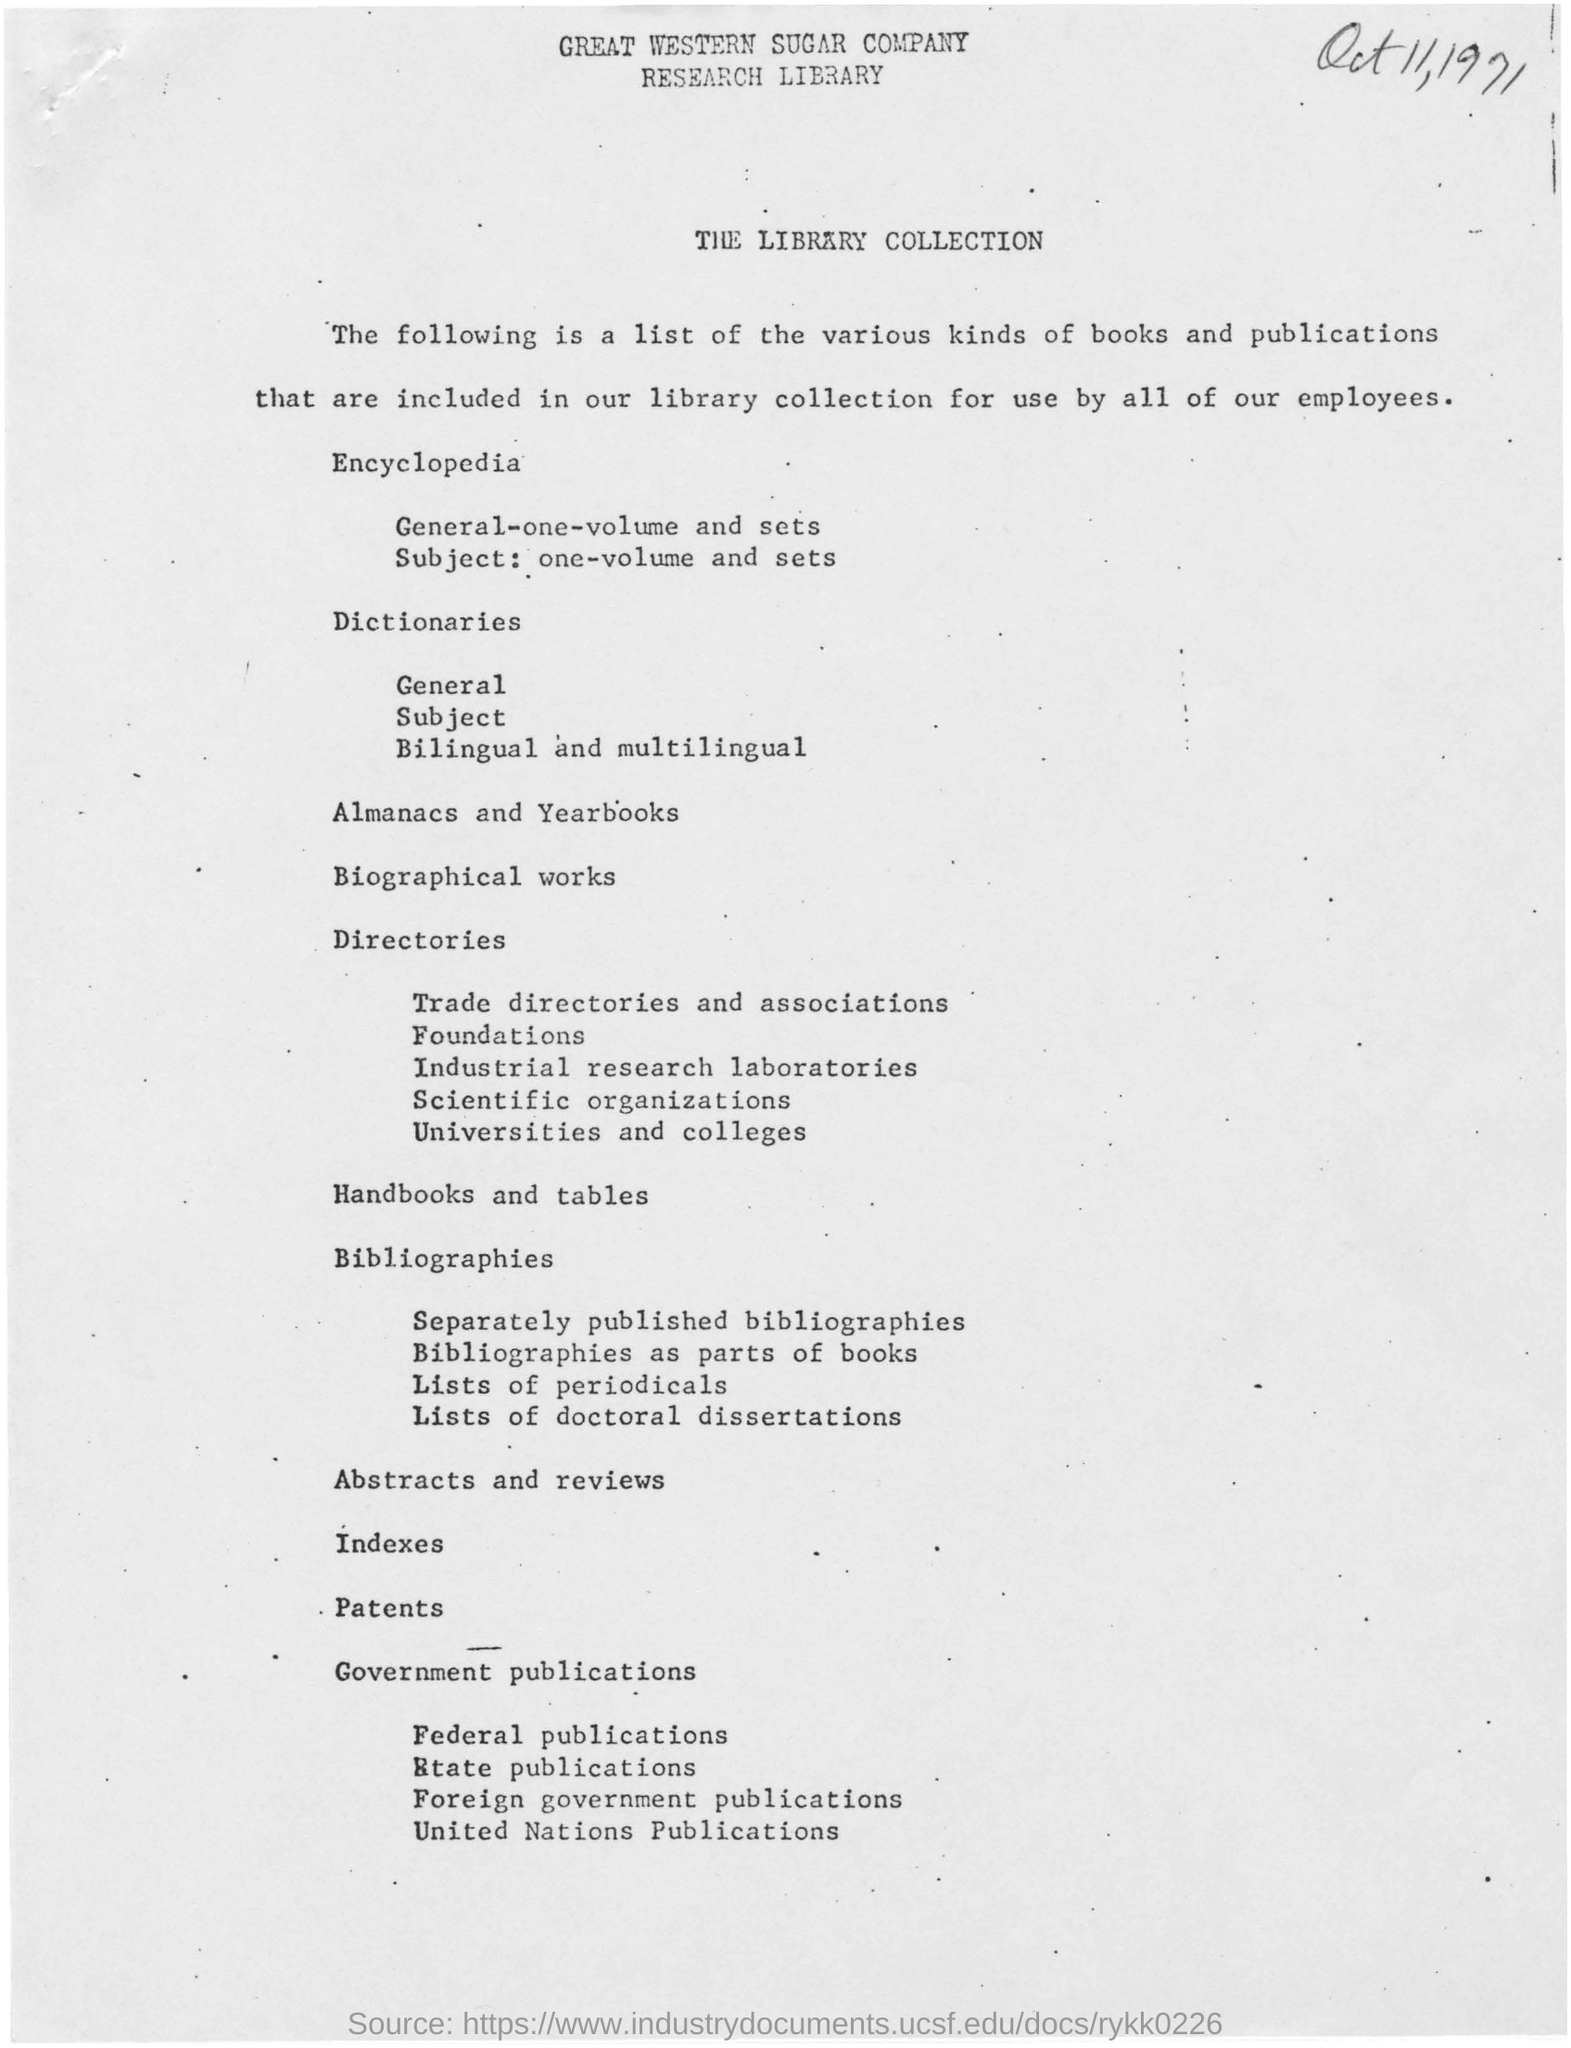Name of the company mentioned on top of the document
Offer a very short reply. GREAT WESTERN SUGAR COMPANY. Where are the list of various kinds of books and publications included?
Provide a succinct answer. In our library collection for use by all of our employees. For whose use are the books and publications are included in library collection
Provide a short and direct response. ALL OF OUR EMPLOYEES. 